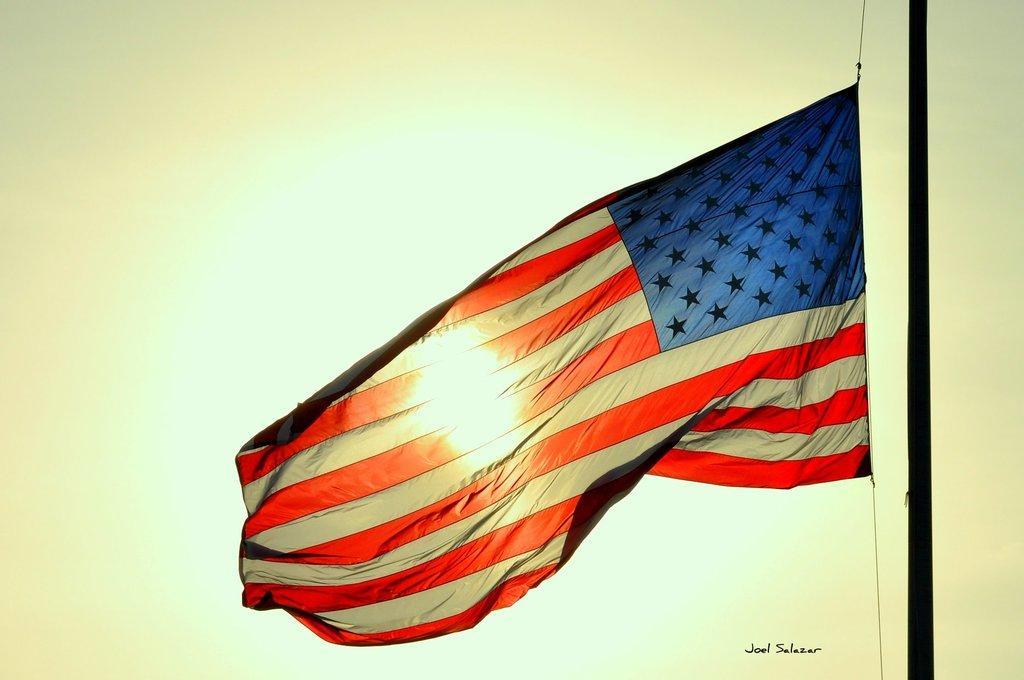Please provide a concise description of this image. In this picture we can see a flag and a pole. There is some text visible in the bottom right. 